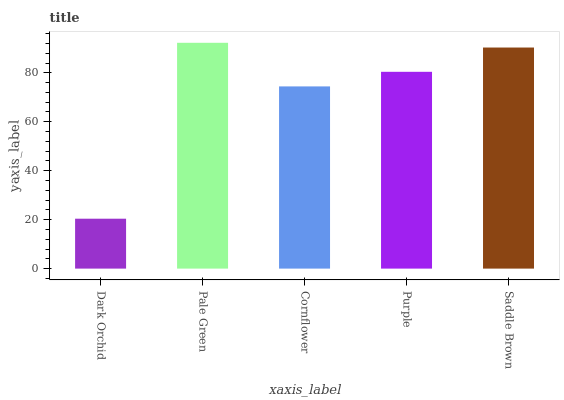Is Dark Orchid the minimum?
Answer yes or no. Yes. Is Pale Green the maximum?
Answer yes or no. Yes. Is Cornflower the minimum?
Answer yes or no. No. Is Cornflower the maximum?
Answer yes or no. No. Is Pale Green greater than Cornflower?
Answer yes or no. Yes. Is Cornflower less than Pale Green?
Answer yes or no. Yes. Is Cornflower greater than Pale Green?
Answer yes or no. No. Is Pale Green less than Cornflower?
Answer yes or no. No. Is Purple the high median?
Answer yes or no. Yes. Is Purple the low median?
Answer yes or no. Yes. Is Cornflower the high median?
Answer yes or no. No. Is Dark Orchid the low median?
Answer yes or no. No. 